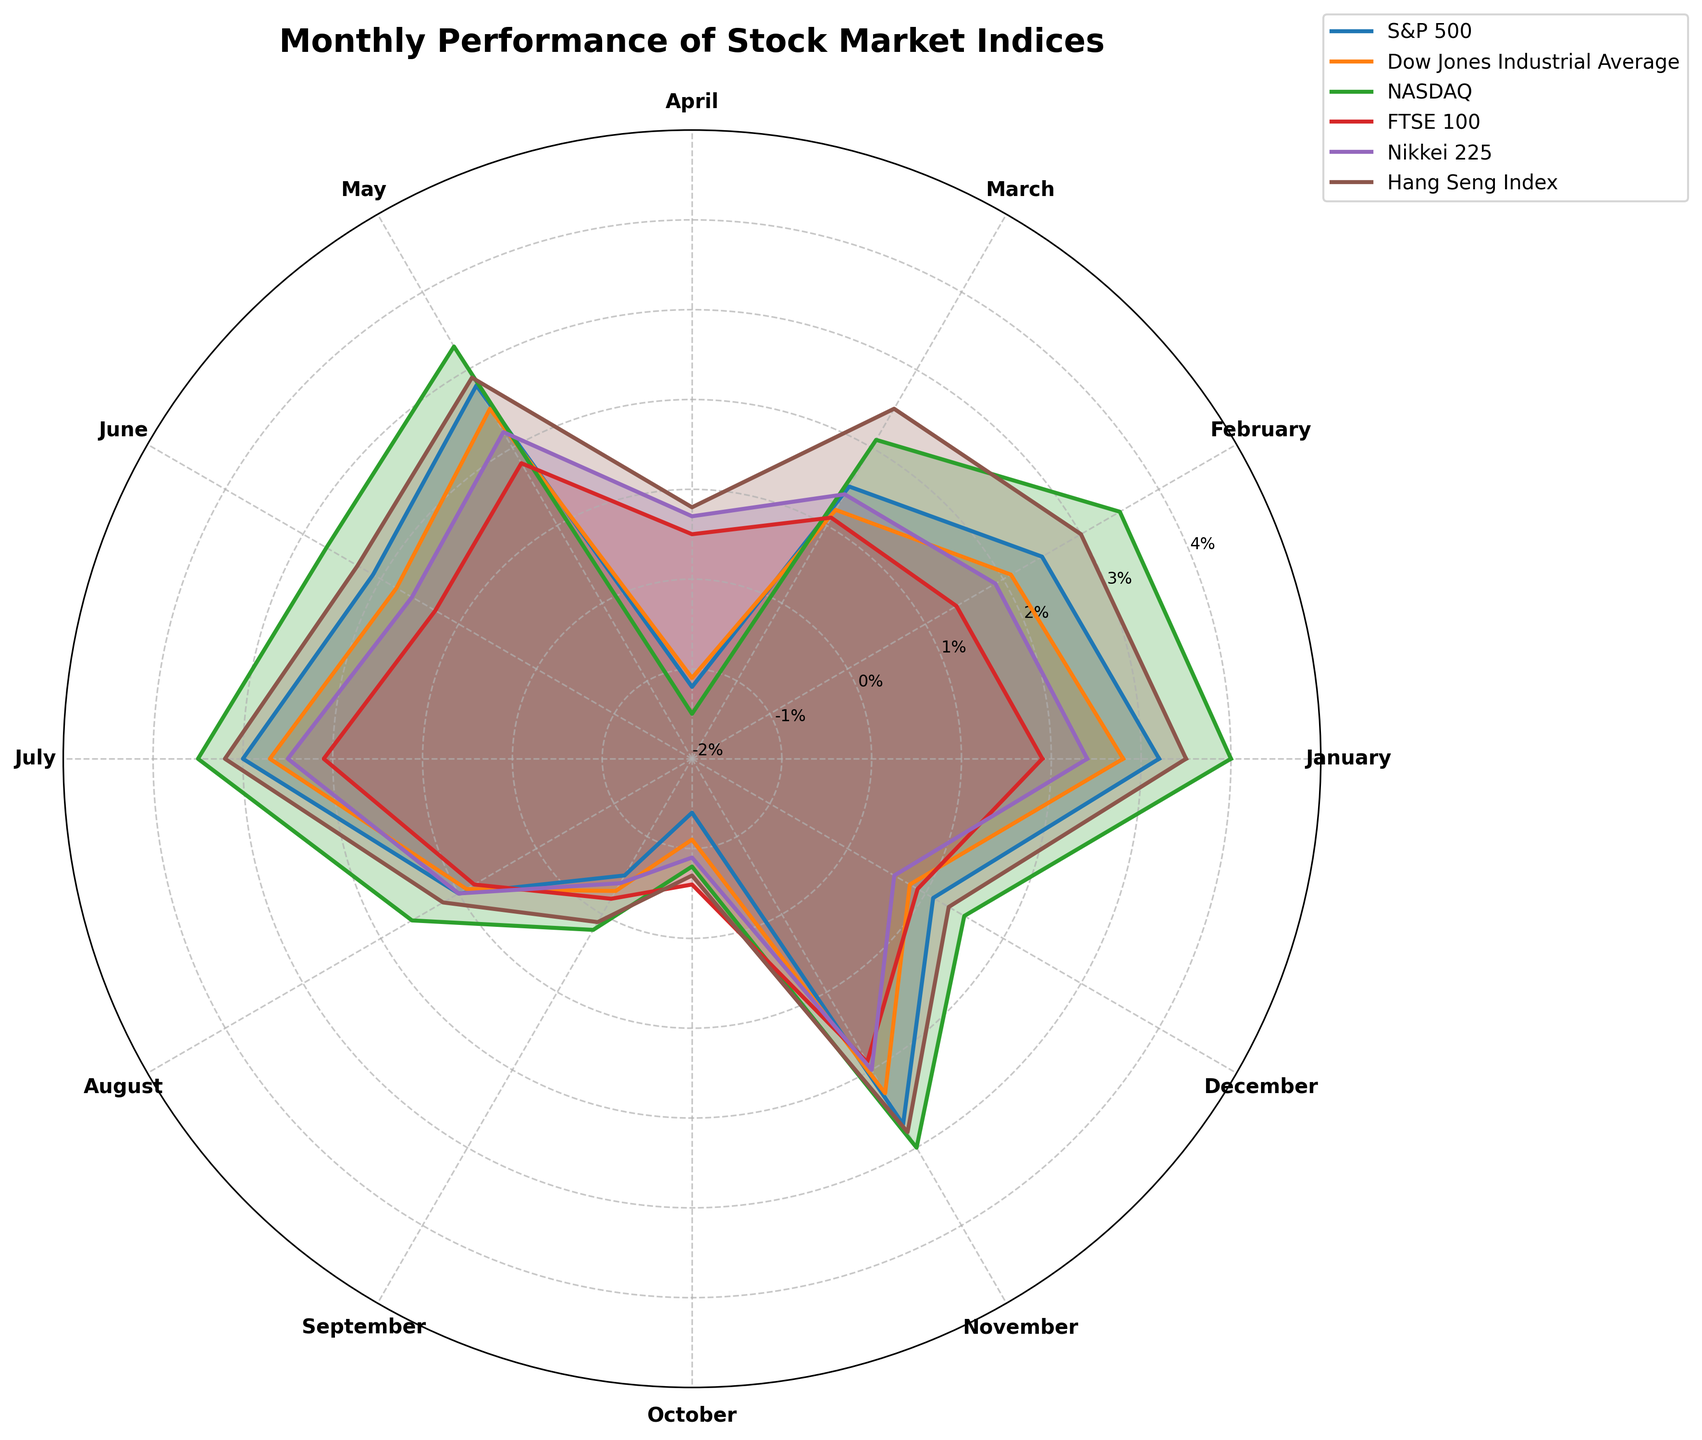What's the title of the figure? The title of the figure is displayed at the top of the chart, positioned centrally in bold font.
Answer: Monthly Performance of Stock Market Indices What is the performance of NASDAQ in March? By looking at the March label on the polar chart and tracing the corresponding data point for NASDAQ, we find the performance value.
Answer: 2.1% Which index had the highest performance in January? Comparing the data points for January on the polar chart for all indices (S&P 500, Dow Jones, NASDAQ, FTSE 100, Nikkei 225, and Hang Seng Index) shows the highest value.
Answer: NASDAQ Which months did the S&P 500 have negative performance? By identifying the months where the S&P 500 data points are below the central axis (0% line), we get the negative performance months.
Answer: April, September, October What is the average performance of the Dow Jones in the first quarter (January-March)? Adding the performance values for Dow Jones for January, February, and March (2.8 + 2.1 + 1.2), then dividing the sum by 3 gives the average.
Answer: 2.033% Which index showed a decline in performance in both August and September? Observing the runs between August and September for all indices and identifying which index has a downward trend in both months gives us the result.
Answer: Dow Jones, S&P 500, Nikkei 225 What was the range of performance for the FTSE 100 throughout the year? The range is calculated by subtracting the minimum performance value from the maximum performance value of FTSE 100 across all months.
Answer: 2.3% Which month showed the overall highest performance across all indices? By comparing the data points for each month across all indices, we identify the month with the highest value.
Answer: January In which months did all indices exhibit positive performance? By checking each month's data points across all indices and noting where all entries are above the central axis (0% line) identifies the consistent positive performance months.
Answer: January, February, March, May, June, July, August, November, December 